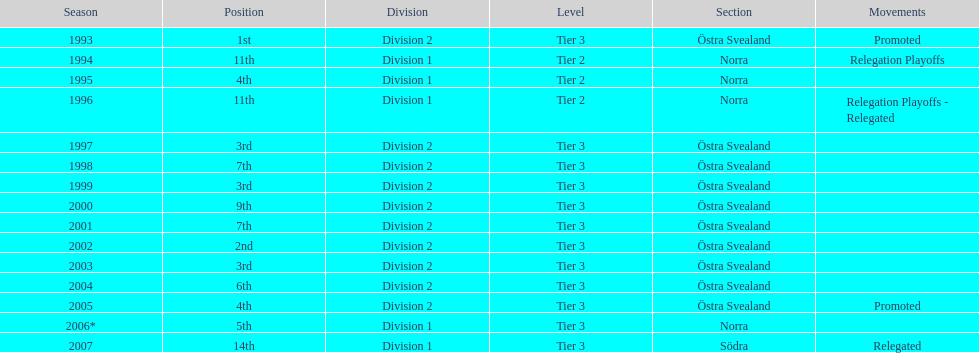In total, how many times were they promoted? 2. 